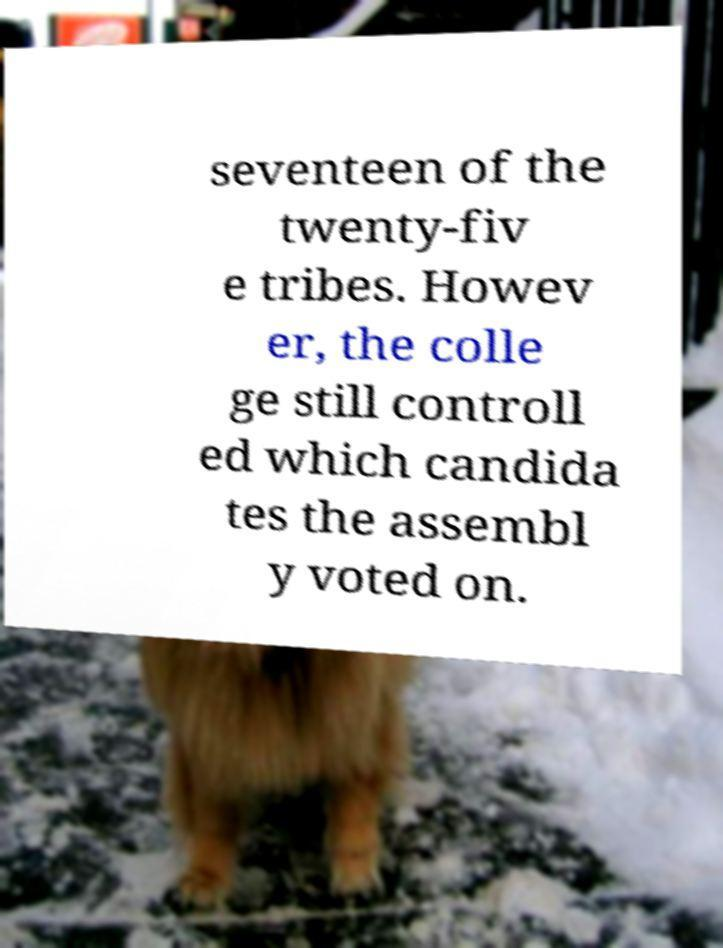What messages or text are displayed in this image? I need them in a readable, typed format. seventeen of the twenty-fiv e tribes. Howev er, the colle ge still controll ed which candida tes the assembl y voted on. 